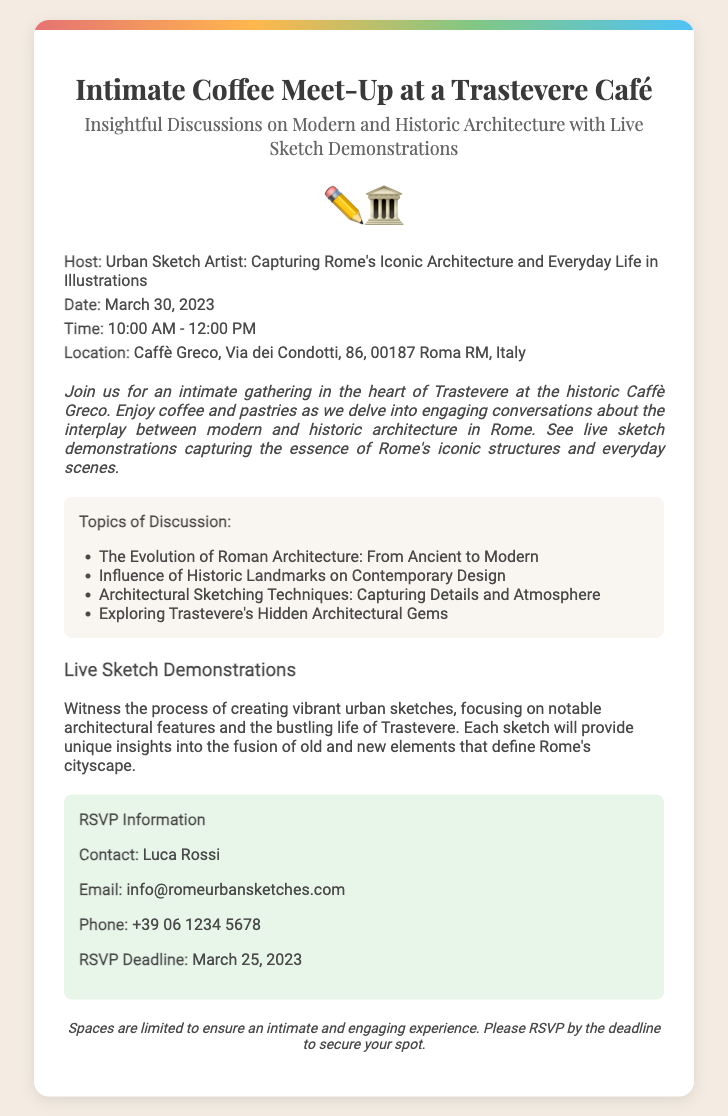what is the name of the café? The café where the meet-up will take place is mentioned in the location section of the document.
Answer: Caffè Greco who is the host of the event? The host is specified at the beginning under the event details.
Answer: Urban Sketch Artist what is the date of the meet-up? The date is provided in the event details section.
Answer: March 30, 2023 how long will the meet-up last? The duration is indicated between the start and end times listed in the document.
Answer: 2 hours what are the topics of discussion? The topics are listed as bullet points in the topics section of the document.
Answer: The Evolution of Roman Architecture: From Ancient to Modern what is the RSVP deadline? The RSVP deadline is specified in the RSVP information section.
Answer: March 25, 2023 how can I contact the host? The contact details are provided within the RSVP information section.
Answer: info@romeurbansketches.com why is the event limited in space? The note at the end of the document explains the reason for the limited spaces for the meet-up.
Answer: To ensure an intimate and engaging experience what type of demonstrations will take place? The live sketch section describes the activities that will occur during the event.
Answer: Live Sketch Demonstrations 